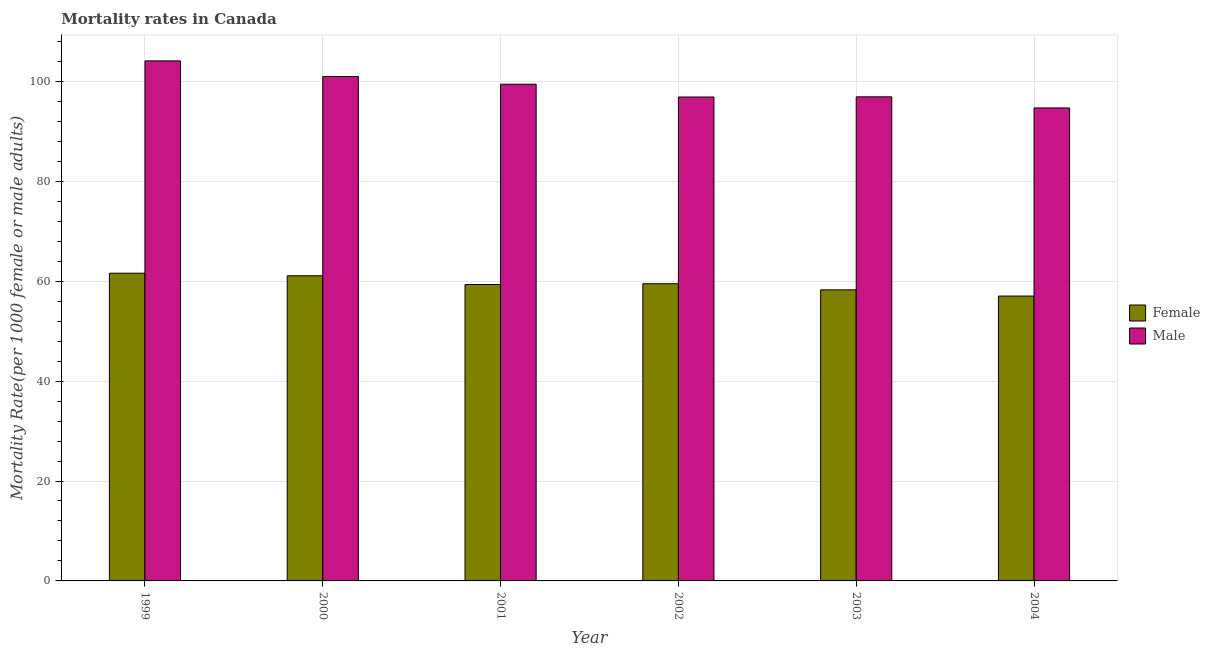How many different coloured bars are there?
Give a very brief answer. 2. Are the number of bars per tick equal to the number of legend labels?
Your answer should be compact. Yes. Are the number of bars on each tick of the X-axis equal?
Provide a succinct answer. Yes. What is the label of the 2nd group of bars from the left?
Keep it short and to the point. 2000. What is the male mortality rate in 2002?
Your answer should be compact. 96.86. Across all years, what is the maximum female mortality rate?
Your answer should be very brief. 61.59. Across all years, what is the minimum male mortality rate?
Your answer should be compact. 94.67. In which year was the male mortality rate maximum?
Give a very brief answer. 1999. What is the total male mortality rate in the graph?
Your response must be concise. 592.9. What is the difference between the female mortality rate in 1999 and that in 2003?
Offer a terse response. 3.33. What is the difference between the female mortality rate in 2003 and the male mortality rate in 2001?
Ensure brevity in your answer.  -1.07. What is the average female mortality rate per year?
Make the answer very short. 59.46. What is the ratio of the male mortality rate in 2001 to that in 2003?
Your answer should be compact. 1.03. Is the difference between the male mortality rate in 2002 and 2003 greater than the difference between the female mortality rate in 2002 and 2003?
Your response must be concise. No. What is the difference between the highest and the second highest female mortality rate?
Offer a terse response. 0.52. What is the difference between the highest and the lowest male mortality rate?
Make the answer very short. 9.42. Is the sum of the male mortality rate in 2000 and 2003 greater than the maximum female mortality rate across all years?
Your answer should be very brief. Yes. What does the 1st bar from the right in 2003 represents?
Your response must be concise. Male. How many years are there in the graph?
Ensure brevity in your answer.  6. Does the graph contain any zero values?
Give a very brief answer. No. Does the graph contain grids?
Your response must be concise. Yes. How many legend labels are there?
Ensure brevity in your answer.  2. How are the legend labels stacked?
Give a very brief answer. Vertical. What is the title of the graph?
Ensure brevity in your answer.  Mortality rates in Canada. What is the label or title of the Y-axis?
Provide a succinct answer. Mortality Rate(per 1000 female or male adults). What is the Mortality Rate(per 1000 female or male adults) in Female in 1999?
Keep it short and to the point. 61.59. What is the Mortality Rate(per 1000 female or male adults) in Male in 1999?
Provide a succinct answer. 104.09. What is the Mortality Rate(per 1000 female or male adults) of Female in 2000?
Offer a terse response. 61.08. What is the Mortality Rate(per 1000 female or male adults) of Male in 2000?
Ensure brevity in your answer.  100.97. What is the Mortality Rate(per 1000 female or male adults) of Female in 2001?
Offer a very short reply. 59.33. What is the Mortality Rate(per 1000 female or male adults) in Male in 2001?
Your response must be concise. 99.42. What is the Mortality Rate(per 1000 female or male adults) in Female in 2002?
Make the answer very short. 59.49. What is the Mortality Rate(per 1000 female or male adults) in Male in 2002?
Your answer should be very brief. 96.86. What is the Mortality Rate(per 1000 female or male adults) of Female in 2003?
Offer a very short reply. 58.26. What is the Mortality Rate(per 1000 female or male adults) in Male in 2003?
Ensure brevity in your answer.  96.89. What is the Mortality Rate(per 1000 female or male adults) of Female in 2004?
Your response must be concise. 57.02. What is the Mortality Rate(per 1000 female or male adults) in Male in 2004?
Keep it short and to the point. 94.67. Across all years, what is the maximum Mortality Rate(per 1000 female or male adults) in Female?
Your response must be concise. 61.59. Across all years, what is the maximum Mortality Rate(per 1000 female or male adults) of Male?
Keep it short and to the point. 104.09. Across all years, what is the minimum Mortality Rate(per 1000 female or male adults) of Female?
Ensure brevity in your answer.  57.02. Across all years, what is the minimum Mortality Rate(per 1000 female or male adults) in Male?
Offer a very short reply. 94.67. What is the total Mortality Rate(per 1000 female or male adults) of Female in the graph?
Offer a terse response. 356.77. What is the total Mortality Rate(per 1000 female or male adults) of Male in the graph?
Ensure brevity in your answer.  592.9. What is the difference between the Mortality Rate(per 1000 female or male adults) of Female in 1999 and that in 2000?
Your response must be concise. 0.52. What is the difference between the Mortality Rate(per 1000 female or male adults) of Male in 1999 and that in 2000?
Offer a very short reply. 3.12. What is the difference between the Mortality Rate(per 1000 female or male adults) of Female in 1999 and that in 2001?
Your response must be concise. 2.26. What is the difference between the Mortality Rate(per 1000 female or male adults) in Male in 1999 and that in 2001?
Offer a terse response. 4.67. What is the difference between the Mortality Rate(per 1000 female or male adults) of Female in 1999 and that in 2002?
Ensure brevity in your answer.  2.1. What is the difference between the Mortality Rate(per 1000 female or male adults) of Male in 1999 and that in 2002?
Your answer should be compact. 7.23. What is the difference between the Mortality Rate(per 1000 female or male adults) of Female in 1999 and that in 2003?
Your response must be concise. 3.33. What is the difference between the Mortality Rate(per 1000 female or male adults) of Male in 1999 and that in 2003?
Ensure brevity in your answer.  7.2. What is the difference between the Mortality Rate(per 1000 female or male adults) in Female in 1999 and that in 2004?
Provide a succinct answer. 4.57. What is the difference between the Mortality Rate(per 1000 female or male adults) in Male in 1999 and that in 2004?
Your answer should be very brief. 9.42. What is the difference between the Mortality Rate(per 1000 female or male adults) of Female in 2000 and that in 2001?
Your response must be concise. 1.75. What is the difference between the Mortality Rate(per 1000 female or male adults) of Male in 2000 and that in 2001?
Offer a very short reply. 1.55. What is the difference between the Mortality Rate(per 1000 female or male adults) of Female in 2000 and that in 2002?
Give a very brief answer. 1.59. What is the difference between the Mortality Rate(per 1000 female or male adults) in Male in 2000 and that in 2002?
Offer a terse response. 4.11. What is the difference between the Mortality Rate(per 1000 female or male adults) in Female in 2000 and that in 2003?
Provide a short and direct response. 2.81. What is the difference between the Mortality Rate(per 1000 female or male adults) of Male in 2000 and that in 2003?
Provide a short and direct response. 4.07. What is the difference between the Mortality Rate(per 1000 female or male adults) in Female in 2000 and that in 2004?
Make the answer very short. 4.06. What is the difference between the Mortality Rate(per 1000 female or male adults) of Male in 2000 and that in 2004?
Provide a succinct answer. 6.3. What is the difference between the Mortality Rate(per 1000 female or male adults) of Female in 2001 and that in 2002?
Your answer should be very brief. -0.16. What is the difference between the Mortality Rate(per 1000 female or male adults) in Male in 2001 and that in 2002?
Provide a succinct answer. 2.56. What is the difference between the Mortality Rate(per 1000 female or male adults) in Female in 2001 and that in 2003?
Offer a very short reply. 1.07. What is the difference between the Mortality Rate(per 1000 female or male adults) of Male in 2001 and that in 2003?
Keep it short and to the point. 2.53. What is the difference between the Mortality Rate(per 1000 female or male adults) of Female in 2001 and that in 2004?
Give a very brief answer. 2.31. What is the difference between the Mortality Rate(per 1000 female or male adults) in Male in 2001 and that in 2004?
Ensure brevity in your answer.  4.75. What is the difference between the Mortality Rate(per 1000 female or male adults) in Female in 2002 and that in 2003?
Keep it short and to the point. 1.23. What is the difference between the Mortality Rate(per 1000 female or male adults) in Male in 2002 and that in 2003?
Give a very brief answer. -0.03. What is the difference between the Mortality Rate(per 1000 female or male adults) in Female in 2002 and that in 2004?
Make the answer very short. 2.47. What is the difference between the Mortality Rate(per 1000 female or male adults) of Male in 2002 and that in 2004?
Your answer should be compact. 2.19. What is the difference between the Mortality Rate(per 1000 female or male adults) in Female in 2003 and that in 2004?
Offer a very short reply. 1.24. What is the difference between the Mortality Rate(per 1000 female or male adults) in Male in 2003 and that in 2004?
Offer a terse response. 2.22. What is the difference between the Mortality Rate(per 1000 female or male adults) of Female in 1999 and the Mortality Rate(per 1000 female or male adults) of Male in 2000?
Ensure brevity in your answer.  -39.38. What is the difference between the Mortality Rate(per 1000 female or male adults) of Female in 1999 and the Mortality Rate(per 1000 female or male adults) of Male in 2001?
Make the answer very short. -37.83. What is the difference between the Mortality Rate(per 1000 female or male adults) of Female in 1999 and the Mortality Rate(per 1000 female or male adults) of Male in 2002?
Provide a short and direct response. -35.27. What is the difference between the Mortality Rate(per 1000 female or male adults) of Female in 1999 and the Mortality Rate(per 1000 female or male adults) of Male in 2003?
Make the answer very short. -35.3. What is the difference between the Mortality Rate(per 1000 female or male adults) of Female in 1999 and the Mortality Rate(per 1000 female or male adults) of Male in 2004?
Your response must be concise. -33.08. What is the difference between the Mortality Rate(per 1000 female or male adults) of Female in 2000 and the Mortality Rate(per 1000 female or male adults) of Male in 2001?
Make the answer very short. -38.34. What is the difference between the Mortality Rate(per 1000 female or male adults) in Female in 2000 and the Mortality Rate(per 1000 female or male adults) in Male in 2002?
Keep it short and to the point. -35.78. What is the difference between the Mortality Rate(per 1000 female or male adults) of Female in 2000 and the Mortality Rate(per 1000 female or male adults) of Male in 2003?
Your answer should be very brief. -35.82. What is the difference between the Mortality Rate(per 1000 female or male adults) in Female in 2000 and the Mortality Rate(per 1000 female or male adults) in Male in 2004?
Your answer should be compact. -33.59. What is the difference between the Mortality Rate(per 1000 female or male adults) in Female in 2001 and the Mortality Rate(per 1000 female or male adults) in Male in 2002?
Make the answer very short. -37.53. What is the difference between the Mortality Rate(per 1000 female or male adults) of Female in 2001 and the Mortality Rate(per 1000 female or male adults) of Male in 2003?
Offer a very short reply. -37.56. What is the difference between the Mortality Rate(per 1000 female or male adults) in Female in 2001 and the Mortality Rate(per 1000 female or male adults) in Male in 2004?
Your answer should be compact. -35.34. What is the difference between the Mortality Rate(per 1000 female or male adults) of Female in 2002 and the Mortality Rate(per 1000 female or male adults) of Male in 2003?
Your response must be concise. -37.41. What is the difference between the Mortality Rate(per 1000 female or male adults) in Female in 2002 and the Mortality Rate(per 1000 female or male adults) in Male in 2004?
Offer a very short reply. -35.18. What is the difference between the Mortality Rate(per 1000 female or male adults) in Female in 2003 and the Mortality Rate(per 1000 female or male adults) in Male in 2004?
Your response must be concise. -36.41. What is the average Mortality Rate(per 1000 female or male adults) in Female per year?
Offer a very short reply. 59.46. What is the average Mortality Rate(per 1000 female or male adults) of Male per year?
Ensure brevity in your answer.  98.82. In the year 1999, what is the difference between the Mortality Rate(per 1000 female or male adults) in Female and Mortality Rate(per 1000 female or male adults) in Male?
Offer a terse response. -42.5. In the year 2000, what is the difference between the Mortality Rate(per 1000 female or male adults) of Female and Mortality Rate(per 1000 female or male adults) of Male?
Provide a succinct answer. -39.89. In the year 2001, what is the difference between the Mortality Rate(per 1000 female or male adults) of Female and Mortality Rate(per 1000 female or male adults) of Male?
Give a very brief answer. -40.09. In the year 2002, what is the difference between the Mortality Rate(per 1000 female or male adults) of Female and Mortality Rate(per 1000 female or male adults) of Male?
Your response must be concise. -37.37. In the year 2003, what is the difference between the Mortality Rate(per 1000 female or male adults) of Female and Mortality Rate(per 1000 female or male adults) of Male?
Provide a succinct answer. -38.63. In the year 2004, what is the difference between the Mortality Rate(per 1000 female or male adults) of Female and Mortality Rate(per 1000 female or male adults) of Male?
Your answer should be compact. -37.65. What is the ratio of the Mortality Rate(per 1000 female or male adults) of Female in 1999 to that in 2000?
Make the answer very short. 1.01. What is the ratio of the Mortality Rate(per 1000 female or male adults) of Male in 1999 to that in 2000?
Provide a succinct answer. 1.03. What is the ratio of the Mortality Rate(per 1000 female or male adults) in Female in 1999 to that in 2001?
Keep it short and to the point. 1.04. What is the ratio of the Mortality Rate(per 1000 female or male adults) of Male in 1999 to that in 2001?
Ensure brevity in your answer.  1.05. What is the ratio of the Mortality Rate(per 1000 female or male adults) in Female in 1999 to that in 2002?
Make the answer very short. 1.04. What is the ratio of the Mortality Rate(per 1000 female or male adults) in Male in 1999 to that in 2002?
Give a very brief answer. 1.07. What is the ratio of the Mortality Rate(per 1000 female or male adults) of Female in 1999 to that in 2003?
Offer a very short reply. 1.06. What is the ratio of the Mortality Rate(per 1000 female or male adults) of Male in 1999 to that in 2003?
Offer a very short reply. 1.07. What is the ratio of the Mortality Rate(per 1000 female or male adults) in Female in 1999 to that in 2004?
Make the answer very short. 1.08. What is the ratio of the Mortality Rate(per 1000 female or male adults) in Male in 1999 to that in 2004?
Your response must be concise. 1.1. What is the ratio of the Mortality Rate(per 1000 female or male adults) of Female in 2000 to that in 2001?
Offer a very short reply. 1.03. What is the ratio of the Mortality Rate(per 1000 female or male adults) in Male in 2000 to that in 2001?
Keep it short and to the point. 1.02. What is the ratio of the Mortality Rate(per 1000 female or male adults) in Female in 2000 to that in 2002?
Offer a terse response. 1.03. What is the ratio of the Mortality Rate(per 1000 female or male adults) of Male in 2000 to that in 2002?
Make the answer very short. 1.04. What is the ratio of the Mortality Rate(per 1000 female or male adults) of Female in 2000 to that in 2003?
Make the answer very short. 1.05. What is the ratio of the Mortality Rate(per 1000 female or male adults) of Male in 2000 to that in 2003?
Provide a succinct answer. 1.04. What is the ratio of the Mortality Rate(per 1000 female or male adults) of Female in 2000 to that in 2004?
Give a very brief answer. 1.07. What is the ratio of the Mortality Rate(per 1000 female or male adults) of Male in 2000 to that in 2004?
Provide a succinct answer. 1.07. What is the ratio of the Mortality Rate(per 1000 female or male adults) in Female in 2001 to that in 2002?
Provide a succinct answer. 1. What is the ratio of the Mortality Rate(per 1000 female or male adults) of Male in 2001 to that in 2002?
Provide a short and direct response. 1.03. What is the ratio of the Mortality Rate(per 1000 female or male adults) in Female in 2001 to that in 2003?
Offer a terse response. 1.02. What is the ratio of the Mortality Rate(per 1000 female or male adults) in Male in 2001 to that in 2003?
Make the answer very short. 1.03. What is the ratio of the Mortality Rate(per 1000 female or male adults) of Female in 2001 to that in 2004?
Your response must be concise. 1.04. What is the ratio of the Mortality Rate(per 1000 female or male adults) in Male in 2001 to that in 2004?
Give a very brief answer. 1.05. What is the ratio of the Mortality Rate(per 1000 female or male adults) in Female in 2002 to that in 2003?
Keep it short and to the point. 1.02. What is the ratio of the Mortality Rate(per 1000 female or male adults) of Female in 2002 to that in 2004?
Give a very brief answer. 1.04. What is the ratio of the Mortality Rate(per 1000 female or male adults) in Male in 2002 to that in 2004?
Your response must be concise. 1.02. What is the ratio of the Mortality Rate(per 1000 female or male adults) in Female in 2003 to that in 2004?
Offer a terse response. 1.02. What is the ratio of the Mortality Rate(per 1000 female or male adults) of Male in 2003 to that in 2004?
Keep it short and to the point. 1.02. What is the difference between the highest and the second highest Mortality Rate(per 1000 female or male adults) in Female?
Your answer should be very brief. 0.52. What is the difference between the highest and the second highest Mortality Rate(per 1000 female or male adults) of Male?
Provide a succinct answer. 3.12. What is the difference between the highest and the lowest Mortality Rate(per 1000 female or male adults) of Female?
Offer a very short reply. 4.57. What is the difference between the highest and the lowest Mortality Rate(per 1000 female or male adults) of Male?
Your response must be concise. 9.42. 